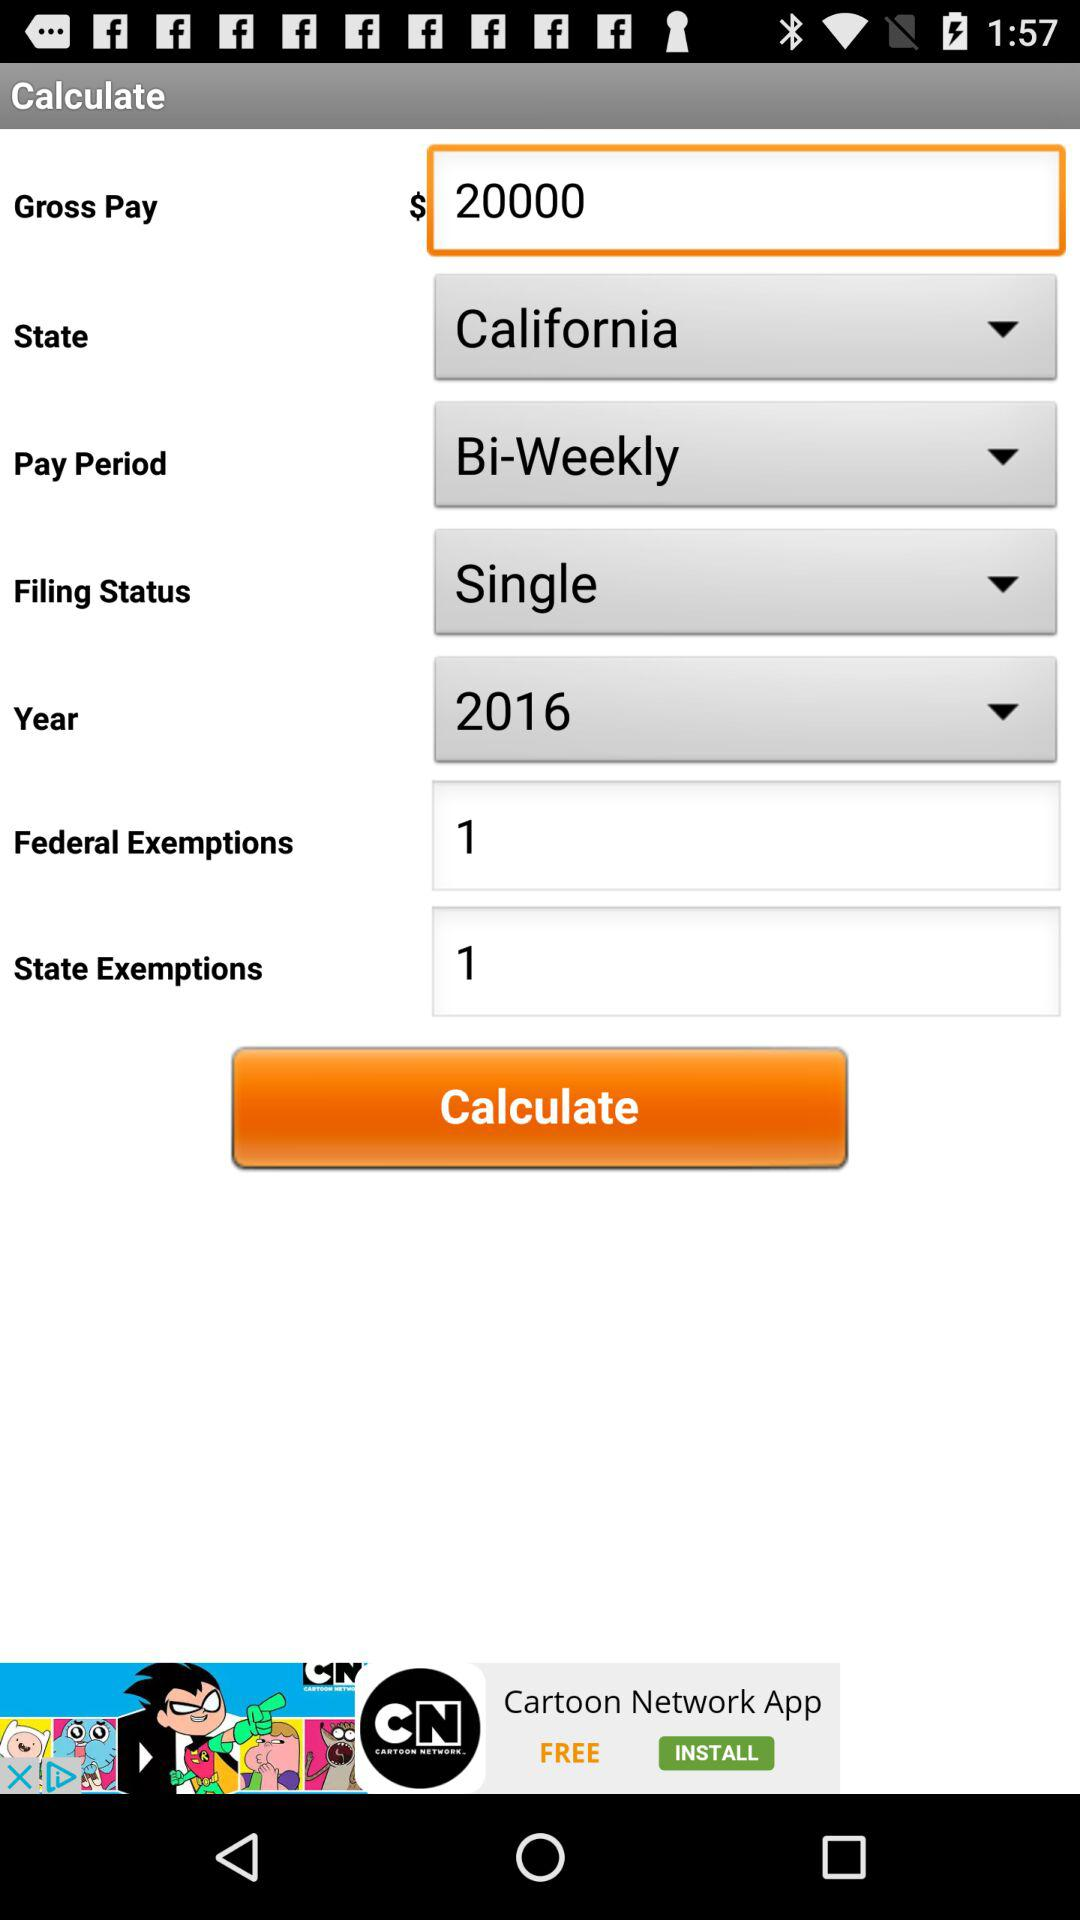What is the "Federal Exemptions"? The "Federal Exemptions" is 1. 